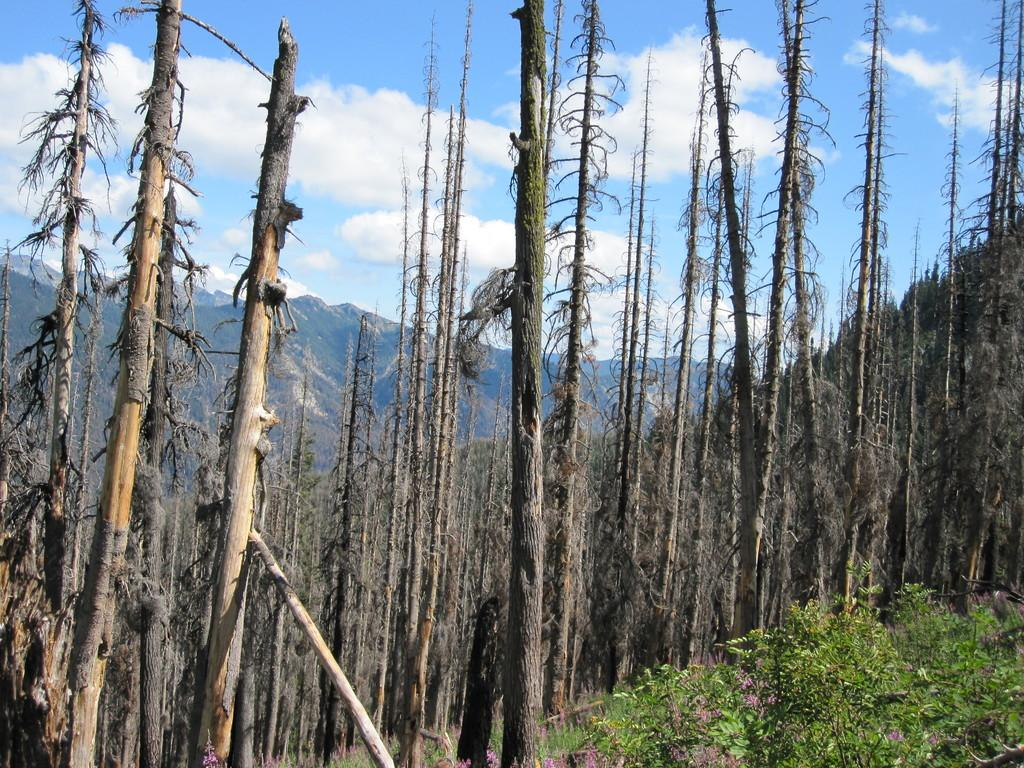What type of vegetation can be seen in the image? There are trees and plants in the image. What is visible in the background of the image? The background of the image includes mountains. What can be seen in the sky in the image? The sky is visible in the image, and it is blue in color with clouds present. What type of leather can be seen in the image? There is no leather present in the image. What is the taste of the clouds in the image? Clouds do not have a taste, as they are made of water vapor and are not edible. 